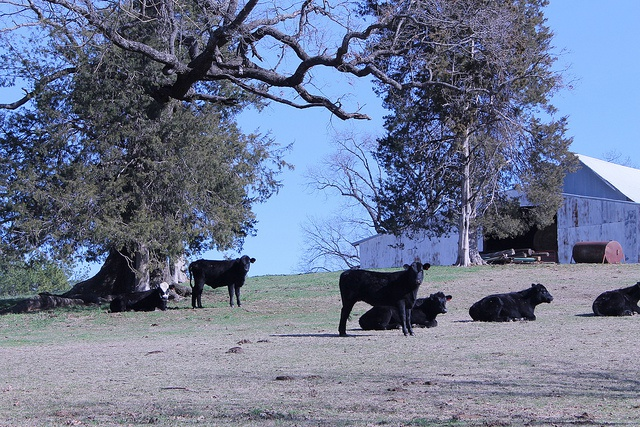Describe the objects in this image and their specific colors. I can see cow in lightblue, black, navy, gray, and darkgray tones, cow in lightblue, black, navy, darkgray, and gray tones, cow in lightblue, black, navy, and gray tones, cow in lightblue, black, gray, and darkgray tones, and cow in lightblue, black, navy, gray, and darkgray tones in this image. 